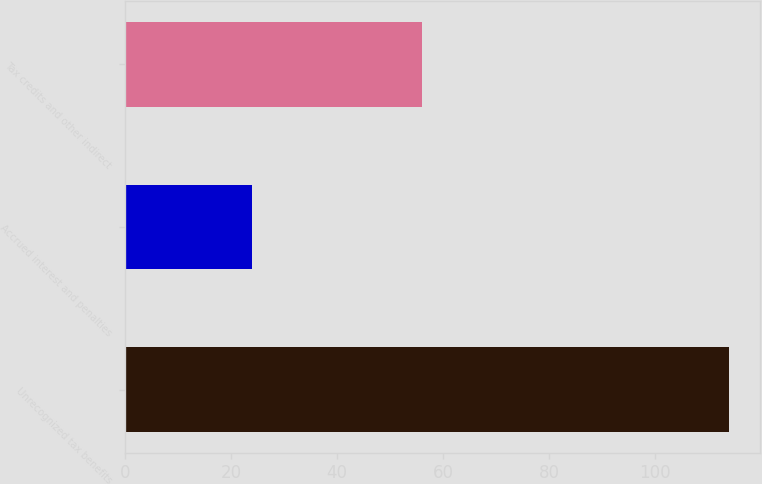Convert chart. <chart><loc_0><loc_0><loc_500><loc_500><bar_chart><fcel>Unrecognized tax benefits<fcel>Accrued interest and penalties<fcel>Tax credits and other indirect<nl><fcel>114<fcel>24<fcel>56<nl></chart> 